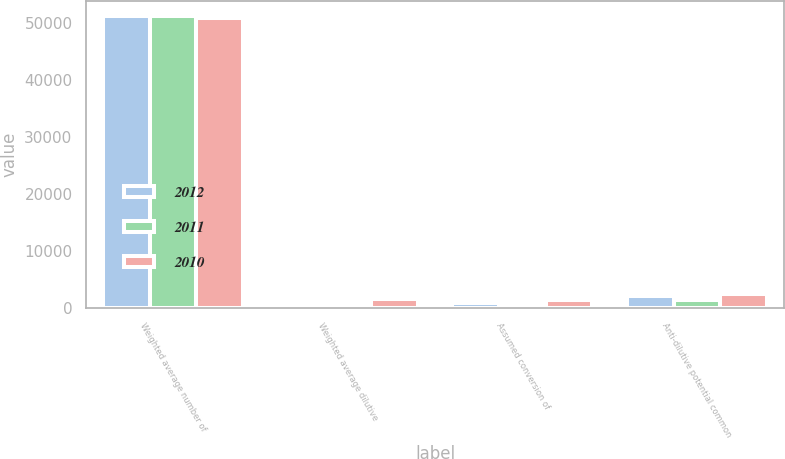Convert chart. <chart><loc_0><loc_0><loc_500><loc_500><stacked_bar_chart><ecel><fcel>Weighted average number of<fcel>Weighted average dilutive<fcel>Assumed conversion of<fcel>Anti-dilutive potential common<nl><fcel>2012<fcel>51326<fcel>501<fcel>985<fcel>2202<nl><fcel>2011<fcel>51211<fcel>828<fcel>729<fcel>1453<nl><fcel>2010<fcel>50988<fcel>1628<fcel>1405<fcel>2487<nl></chart> 